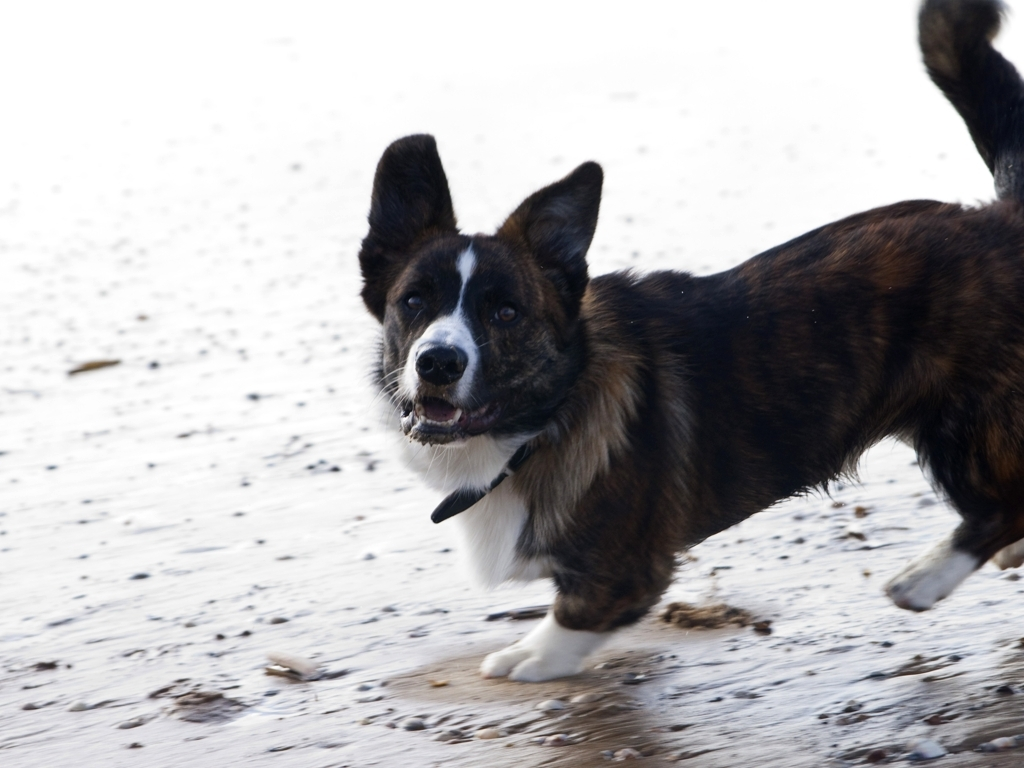Does the brown corgi retain most of its texture details? Yes, the image quality is high enough that the brown corgi’s fur texture is extensive and well-defined. You can clearly see individual strands of fur, and there is a good contrast between the darker and lighter areas, which contributes to the perceived texture detail. 